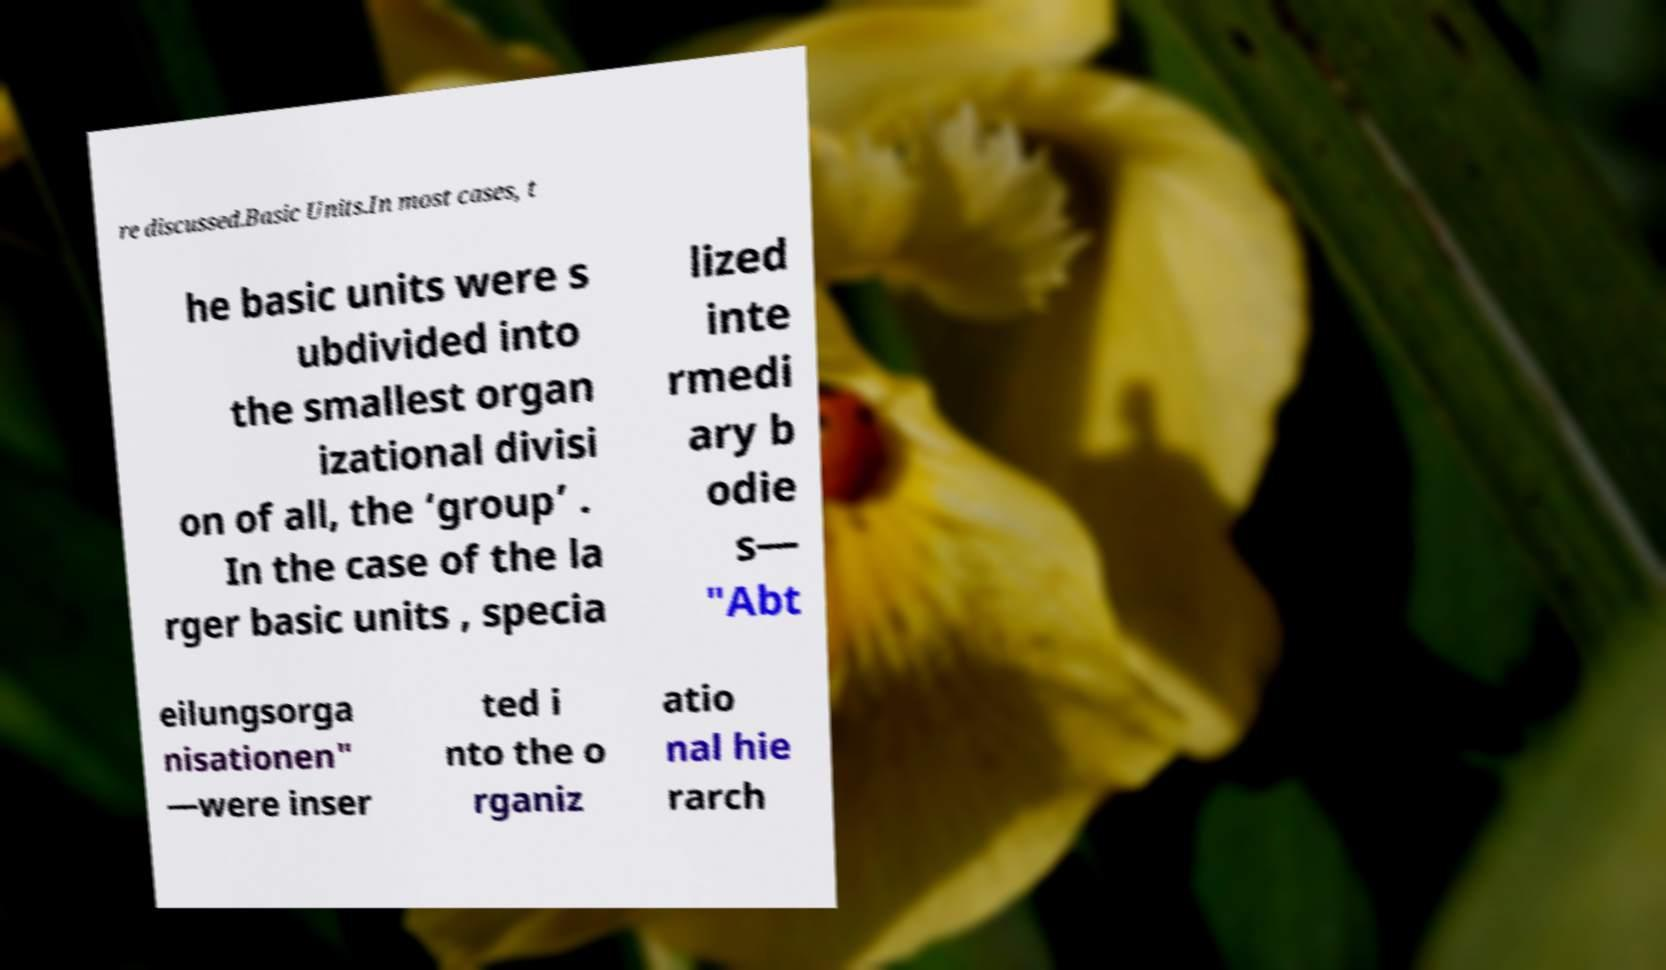Please identify and transcribe the text found in this image. re discussed.Basic Units.In most cases, t he basic units were s ubdivided into the smallest organ izational divisi on of all, the ‘group’ . In the case of the la rger basic units , specia lized inte rmedi ary b odie s— "Abt eilungsorga nisationen" —were inser ted i nto the o rganiz atio nal hie rarch 